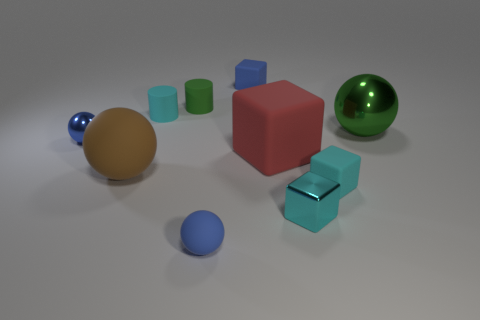Subtract all tiny blocks. How many blocks are left? 1 Subtract all brown spheres. How many cyan cubes are left? 2 Subtract all brown spheres. How many spheres are left? 3 Subtract 2 balls. How many balls are left? 2 Subtract all balls. How many objects are left? 6 Subtract all cyan balls. Subtract all purple cylinders. How many balls are left? 4 Subtract all small blue metallic balls. Subtract all blue metal spheres. How many objects are left? 8 Add 5 big brown rubber spheres. How many big brown rubber spheres are left? 6 Add 1 tiny yellow metallic things. How many tiny yellow metallic things exist? 1 Subtract 1 cyan cylinders. How many objects are left? 9 